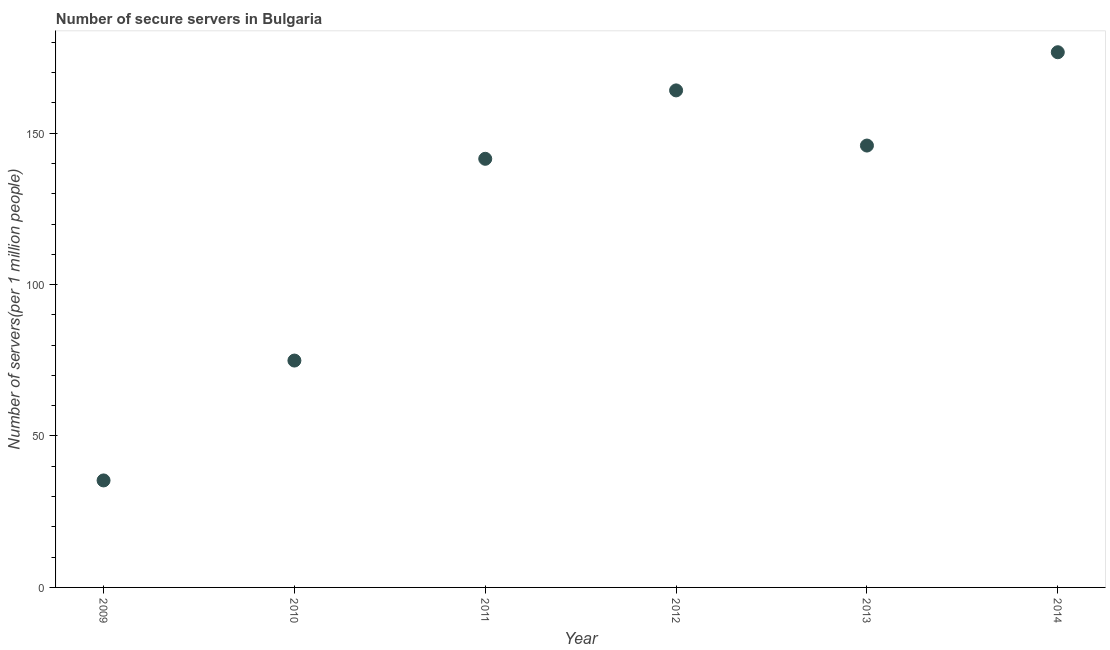What is the number of secure internet servers in 2012?
Offer a very short reply. 164.11. Across all years, what is the maximum number of secure internet servers?
Make the answer very short. 176.72. Across all years, what is the minimum number of secure internet servers?
Make the answer very short. 35.33. What is the sum of the number of secure internet servers?
Your answer should be very brief. 738.5. What is the difference between the number of secure internet servers in 2010 and 2011?
Ensure brevity in your answer.  -66.62. What is the average number of secure internet servers per year?
Provide a short and direct response. 123.08. What is the median number of secure internet servers?
Give a very brief answer. 143.72. In how many years, is the number of secure internet servers greater than 20 ?
Keep it short and to the point. 6. What is the ratio of the number of secure internet servers in 2011 to that in 2014?
Offer a very short reply. 0.8. Is the difference between the number of secure internet servers in 2010 and 2012 greater than the difference between any two years?
Your answer should be very brief. No. What is the difference between the highest and the second highest number of secure internet servers?
Your answer should be compact. 12.6. Is the sum of the number of secure internet servers in 2009 and 2011 greater than the maximum number of secure internet servers across all years?
Offer a terse response. Yes. What is the difference between the highest and the lowest number of secure internet servers?
Keep it short and to the point. 141.39. In how many years, is the number of secure internet servers greater than the average number of secure internet servers taken over all years?
Your response must be concise. 4. Does the number of secure internet servers monotonically increase over the years?
Keep it short and to the point. No. How many years are there in the graph?
Make the answer very short. 6. Does the graph contain any zero values?
Provide a succinct answer. No. Does the graph contain grids?
Provide a succinct answer. No. What is the title of the graph?
Provide a short and direct response. Number of secure servers in Bulgaria. What is the label or title of the X-axis?
Provide a succinct answer. Year. What is the label or title of the Y-axis?
Your response must be concise. Number of servers(per 1 million people). What is the Number of servers(per 1 million people) in 2009?
Make the answer very short. 35.33. What is the Number of servers(per 1 million people) in 2010?
Provide a short and direct response. 74.91. What is the Number of servers(per 1 million people) in 2011?
Offer a very short reply. 141.53. What is the Number of servers(per 1 million people) in 2012?
Keep it short and to the point. 164.11. What is the Number of servers(per 1 million people) in 2013?
Offer a very short reply. 145.9. What is the Number of servers(per 1 million people) in 2014?
Your answer should be compact. 176.72. What is the difference between the Number of servers(per 1 million people) in 2009 and 2010?
Your answer should be very brief. -39.58. What is the difference between the Number of servers(per 1 million people) in 2009 and 2011?
Provide a short and direct response. -106.2. What is the difference between the Number of servers(per 1 million people) in 2009 and 2012?
Provide a succinct answer. -128.79. What is the difference between the Number of servers(per 1 million people) in 2009 and 2013?
Ensure brevity in your answer.  -110.57. What is the difference between the Number of servers(per 1 million people) in 2009 and 2014?
Provide a succinct answer. -141.39. What is the difference between the Number of servers(per 1 million people) in 2010 and 2011?
Make the answer very short. -66.62. What is the difference between the Number of servers(per 1 million people) in 2010 and 2012?
Provide a short and direct response. -89.2. What is the difference between the Number of servers(per 1 million people) in 2010 and 2013?
Keep it short and to the point. -70.99. What is the difference between the Number of servers(per 1 million people) in 2010 and 2014?
Offer a terse response. -101.81. What is the difference between the Number of servers(per 1 million people) in 2011 and 2012?
Your response must be concise. -22.59. What is the difference between the Number of servers(per 1 million people) in 2011 and 2013?
Offer a terse response. -4.37. What is the difference between the Number of servers(per 1 million people) in 2011 and 2014?
Offer a terse response. -35.19. What is the difference between the Number of servers(per 1 million people) in 2012 and 2013?
Ensure brevity in your answer.  18.21. What is the difference between the Number of servers(per 1 million people) in 2012 and 2014?
Provide a succinct answer. -12.6. What is the difference between the Number of servers(per 1 million people) in 2013 and 2014?
Give a very brief answer. -30.81. What is the ratio of the Number of servers(per 1 million people) in 2009 to that in 2010?
Your response must be concise. 0.47. What is the ratio of the Number of servers(per 1 million people) in 2009 to that in 2012?
Keep it short and to the point. 0.21. What is the ratio of the Number of servers(per 1 million people) in 2009 to that in 2013?
Make the answer very short. 0.24. What is the ratio of the Number of servers(per 1 million people) in 2009 to that in 2014?
Your answer should be compact. 0.2. What is the ratio of the Number of servers(per 1 million people) in 2010 to that in 2011?
Your answer should be compact. 0.53. What is the ratio of the Number of servers(per 1 million people) in 2010 to that in 2012?
Your answer should be very brief. 0.46. What is the ratio of the Number of servers(per 1 million people) in 2010 to that in 2013?
Offer a terse response. 0.51. What is the ratio of the Number of servers(per 1 million people) in 2010 to that in 2014?
Your response must be concise. 0.42. What is the ratio of the Number of servers(per 1 million people) in 2011 to that in 2012?
Keep it short and to the point. 0.86. What is the ratio of the Number of servers(per 1 million people) in 2011 to that in 2013?
Keep it short and to the point. 0.97. What is the ratio of the Number of servers(per 1 million people) in 2011 to that in 2014?
Make the answer very short. 0.8. What is the ratio of the Number of servers(per 1 million people) in 2012 to that in 2014?
Offer a very short reply. 0.93. What is the ratio of the Number of servers(per 1 million people) in 2013 to that in 2014?
Keep it short and to the point. 0.83. 